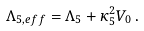<formula> <loc_0><loc_0><loc_500><loc_500>\Lambda _ { 5 , e f f } = \Lambda _ { 5 } + \kappa _ { 5 } ^ { 2 } V _ { 0 } \, .</formula> 